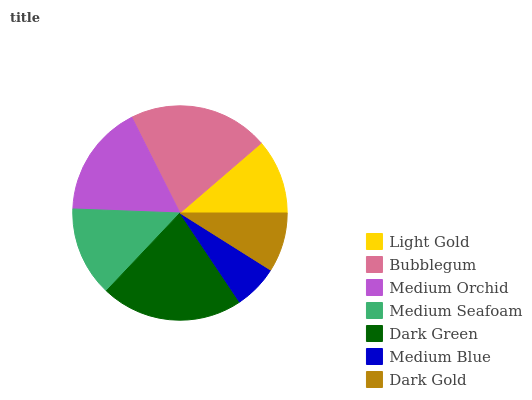Is Medium Blue the minimum?
Answer yes or no. Yes. Is Dark Green the maximum?
Answer yes or no. Yes. Is Bubblegum the minimum?
Answer yes or no. No. Is Bubblegum the maximum?
Answer yes or no. No. Is Bubblegum greater than Light Gold?
Answer yes or no. Yes. Is Light Gold less than Bubblegum?
Answer yes or no. Yes. Is Light Gold greater than Bubblegum?
Answer yes or no. No. Is Bubblegum less than Light Gold?
Answer yes or no. No. Is Medium Seafoam the high median?
Answer yes or no. Yes. Is Medium Seafoam the low median?
Answer yes or no. Yes. Is Medium Blue the high median?
Answer yes or no. No. Is Medium Blue the low median?
Answer yes or no. No. 